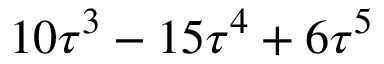Convert formula to latex. <formula><loc_0><loc_0><loc_500><loc_500>1 0 \tau ^ { 3 } - 1 5 \tau ^ { 4 } + 6 \tau ^ { 5 }</formula> 